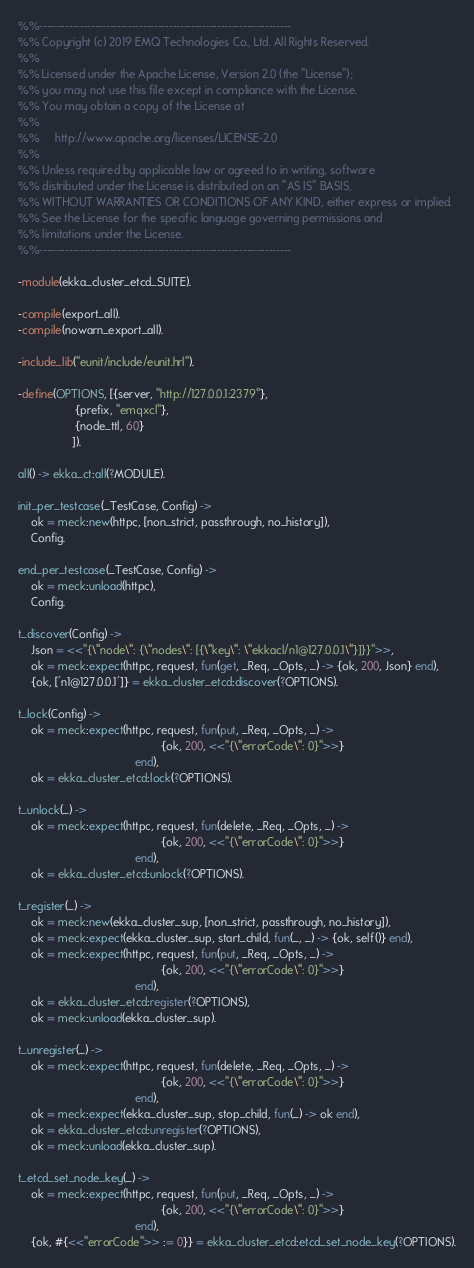<code> <loc_0><loc_0><loc_500><loc_500><_Erlang_>%%--------------------------------------------------------------------
%% Copyright (c) 2019 EMQ Technologies Co., Ltd. All Rights Reserved.
%%
%% Licensed under the Apache License, Version 2.0 (the "License");
%% you may not use this file except in compliance with the License.
%% You may obtain a copy of the License at
%%
%%     http://www.apache.org/licenses/LICENSE-2.0
%%
%% Unless required by applicable law or agreed to in writing, software
%% distributed under the License is distributed on an "AS IS" BASIS,
%% WITHOUT WARRANTIES OR CONDITIONS OF ANY KIND, either express or implied.
%% See the License for the specific language governing permissions and
%% limitations under the License.
%%--------------------------------------------------------------------

-module(ekka_cluster_etcd_SUITE).

-compile(export_all).
-compile(nowarn_export_all).

-include_lib("eunit/include/eunit.hrl").

-define(OPTIONS, [{server, "http://127.0.0.1:2379"},
                  {prefix, "emqxcl"},
                  {node_ttl, 60}
                 ]).

all() -> ekka_ct:all(?MODULE).

init_per_testcase(_TestCase, Config) ->
    ok = meck:new(httpc, [non_strict, passthrough, no_history]),
    Config.

end_per_testcase(_TestCase, Config) ->
    ok = meck:unload(httpc),
    Config.

t_discover(Config) ->
    Json = <<"{\"node\": {\"nodes\": [{\"key\": \"ekkacl/n1@127.0.0.1\"}]}}">>,
    ok = meck:expect(httpc, request, fun(get, _Req, _Opts, _) -> {ok, 200, Json} end),
    {ok, ['n1@127.0.0.1']} = ekka_cluster_etcd:discover(?OPTIONS).

t_lock(Config) ->
    ok = meck:expect(httpc, request, fun(put, _Req, _Opts, _) ->
                                             {ok, 200, <<"{\"errorCode\": 0}">>}
                                     end),
    ok = ekka_cluster_etcd:lock(?OPTIONS).

t_unlock(_) ->
    ok = meck:expect(httpc, request, fun(delete, _Req, _Opts, _) ->
                                             {ok, 200, <<"{\"errorCode\": 0}">>}
                                     end),
    ok = ekka_cluster_etcd:unlock(?OPTIONS).

t_register(_) ->
    ok = meck:new(ekka_cluster_sup, [non_strict, passthrough, no_history]),
    ok = meck:expect(ekka_cluster_sup, start_child, fun(_, _) -> {ok, self()} end),
    ok = meck:expect(httpc, request, fun(put, _Req, _Opts, _) ->
                                             {ok, 200, <<"{\"errorCode\": 0}">>}
                                     end),
    ok = ekka_cluster_etcd:register(?OPTIONS),
    ok = meck:unload(ekka_cluster_sup).

t_unregister(_) ->
    ok = meck:expect(httpc, request, fun(delete, _Req, _Opts, _) ->
                                             {ok, 200, <<"{\"errorCode\": 0}">>}
                                     end),
    ok = meck:expect(ekka_cluster_sup, stop_child, fun(_) -> ok end),
    ok = ekka_cluster_etcd:unregister(?OPTIONS),
    ok = meck:unload(ekka_cluster_sup).

t_etcd_set_node_key(_) ->
    ok = meck:expect(httpc, request, fun(put, _Req, _Opts, _) ->
                                             {ok, 200, <<"{\"errorCode\": 0}">>}
                                     end),
    {ok, #{<<"errorCode">> := 0}} = ekka_cluster_etcd:etcd_set_node_key(?OPTIONS).

</code> 